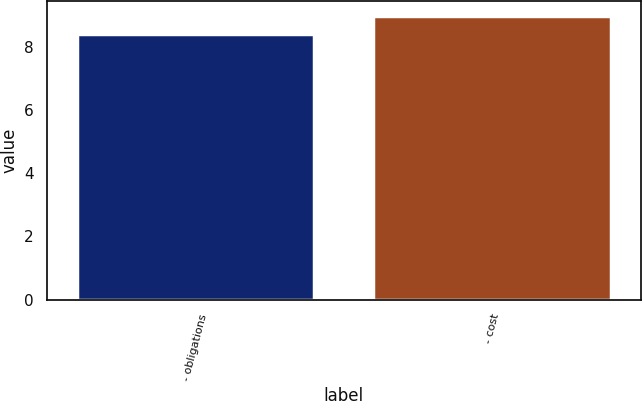Convert chart to OTSL. <chart><loc_0><loc_0><loc_500><loc_500><bar_chart><fcel>- obligations<fcel>- cost<nl><fcel>8.4<fcel>9<nl></chart> 